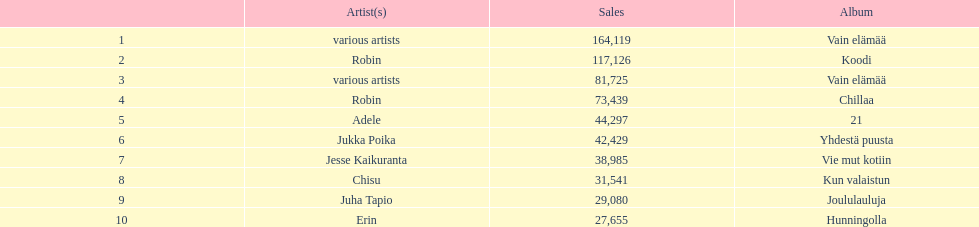Tell me an album that had the same artist as chillaa. Koodi. 